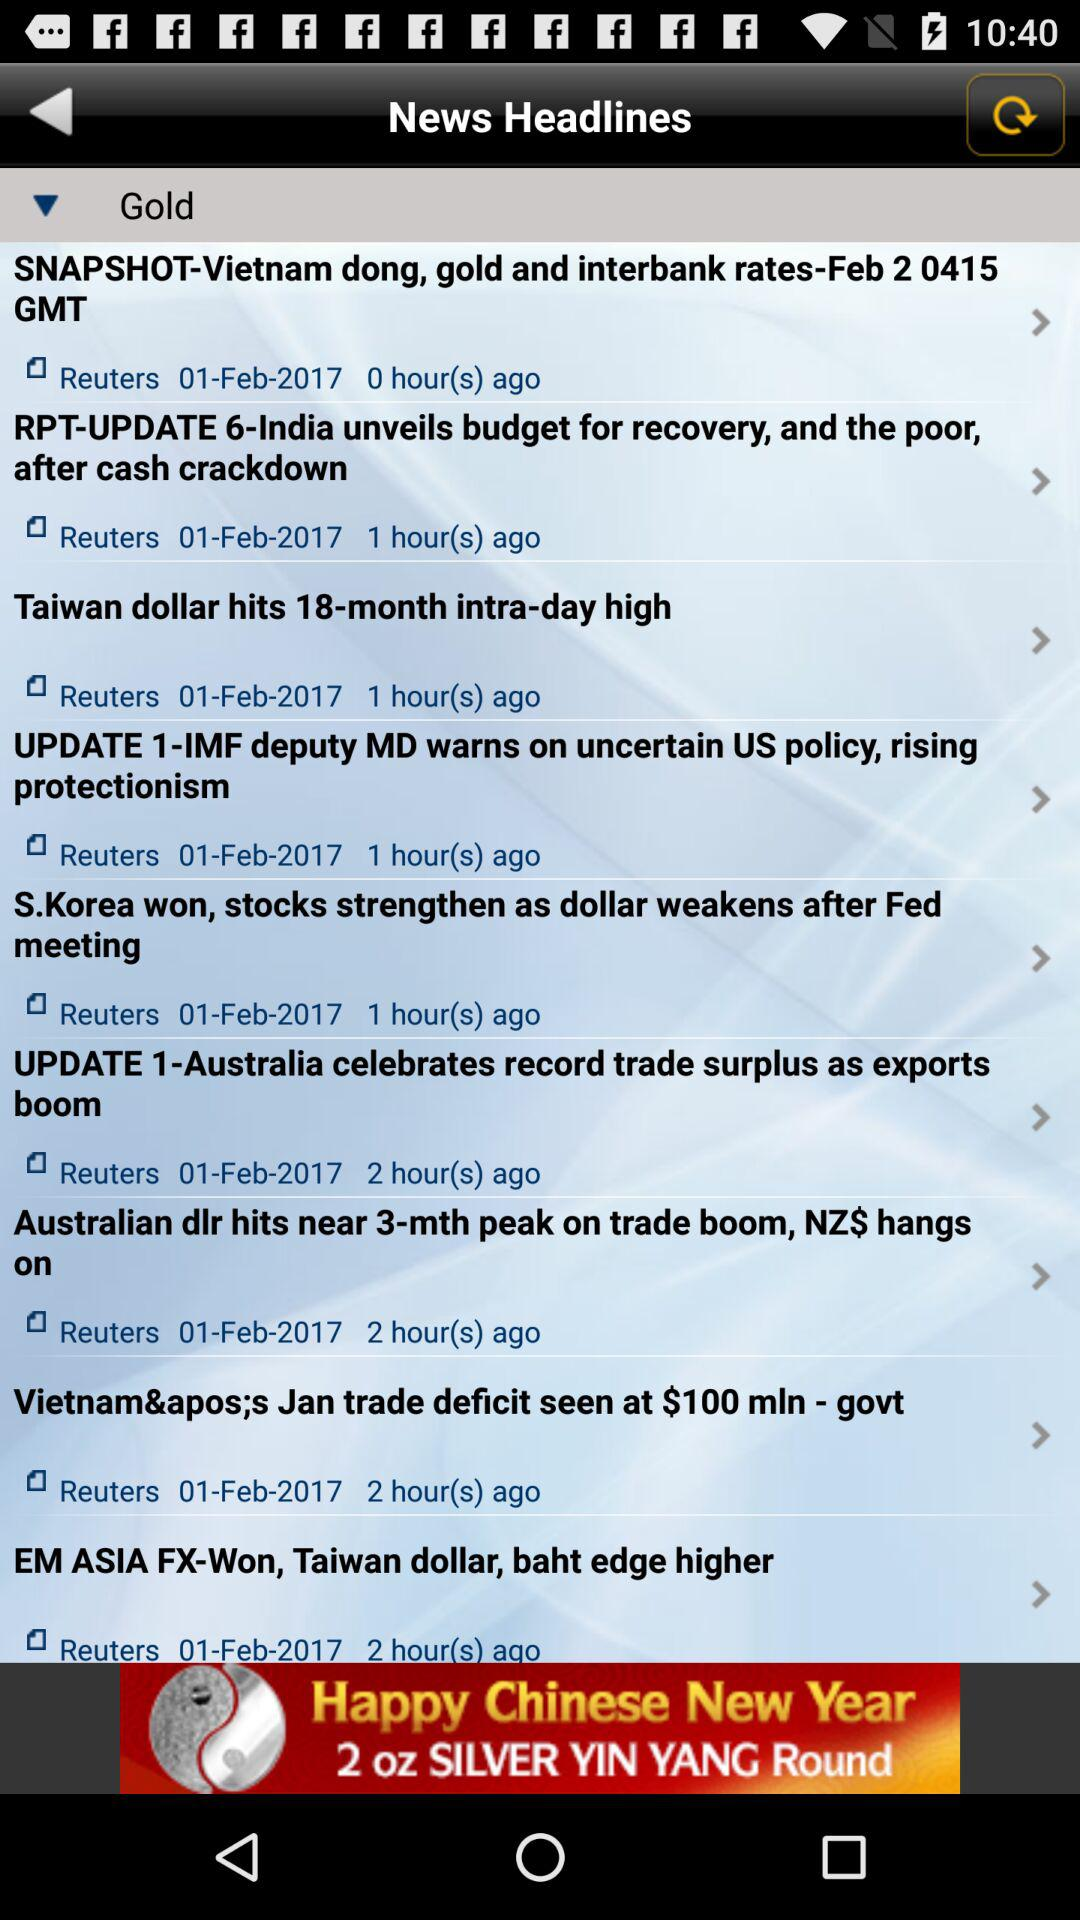What is the date of the news published 0 hours ago? The date is February 1, 2017. 